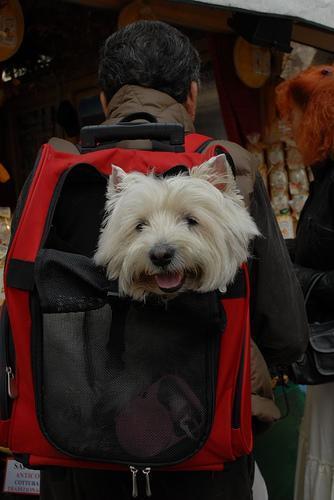How many people can you see?
Give a very brief answer. 2. 